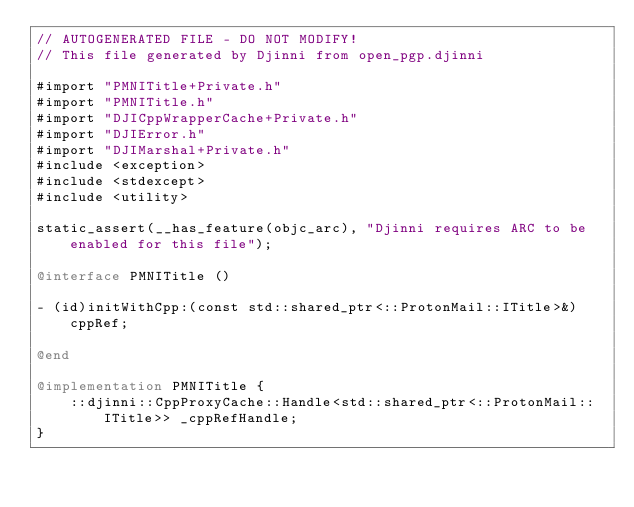Convert code to text. <code><loc_0><loc_0><loc_500><loc_500><_ObjectiveC_>// AUTOGENERATED FILE - DO NOT MODIFY!
// This file generated by Djinni from open_pgp.djinni

#import "PMNITitle+Private.h"
#import "PMNITitle.h"
#import "DJICppWrapperCache+Private.h"
#import "DJIError.h"
#import "DJIMarshal+Private.h"
#include <exception>
#include <stdexcept>
#include <utility>

static_assert(__has_feature(objc_arc), "Djinni requires ARC to be enabled for this file");

@interface PMNITitle ()

- (id)initWithCpp:(const std::shared_ptr<::ProtonMail::ITitle>&)cppRef;

@end

@implementation PMNITitle {
    ::djinni::CppProxyCache::Handle<std::shared_ptr<::ProtonMail::ITitle>> _cppRefHandle;
}
</code> 